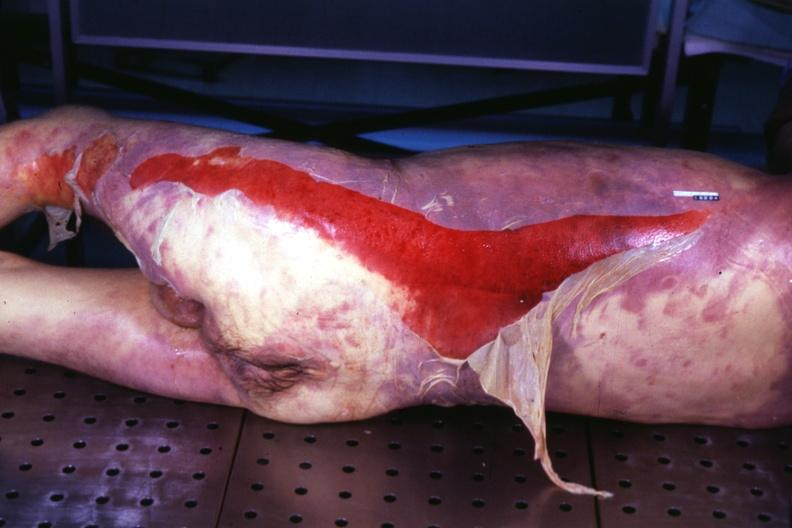s palpable purpura with desquamation present?
Answer the question using a single word or phrase. Yes 